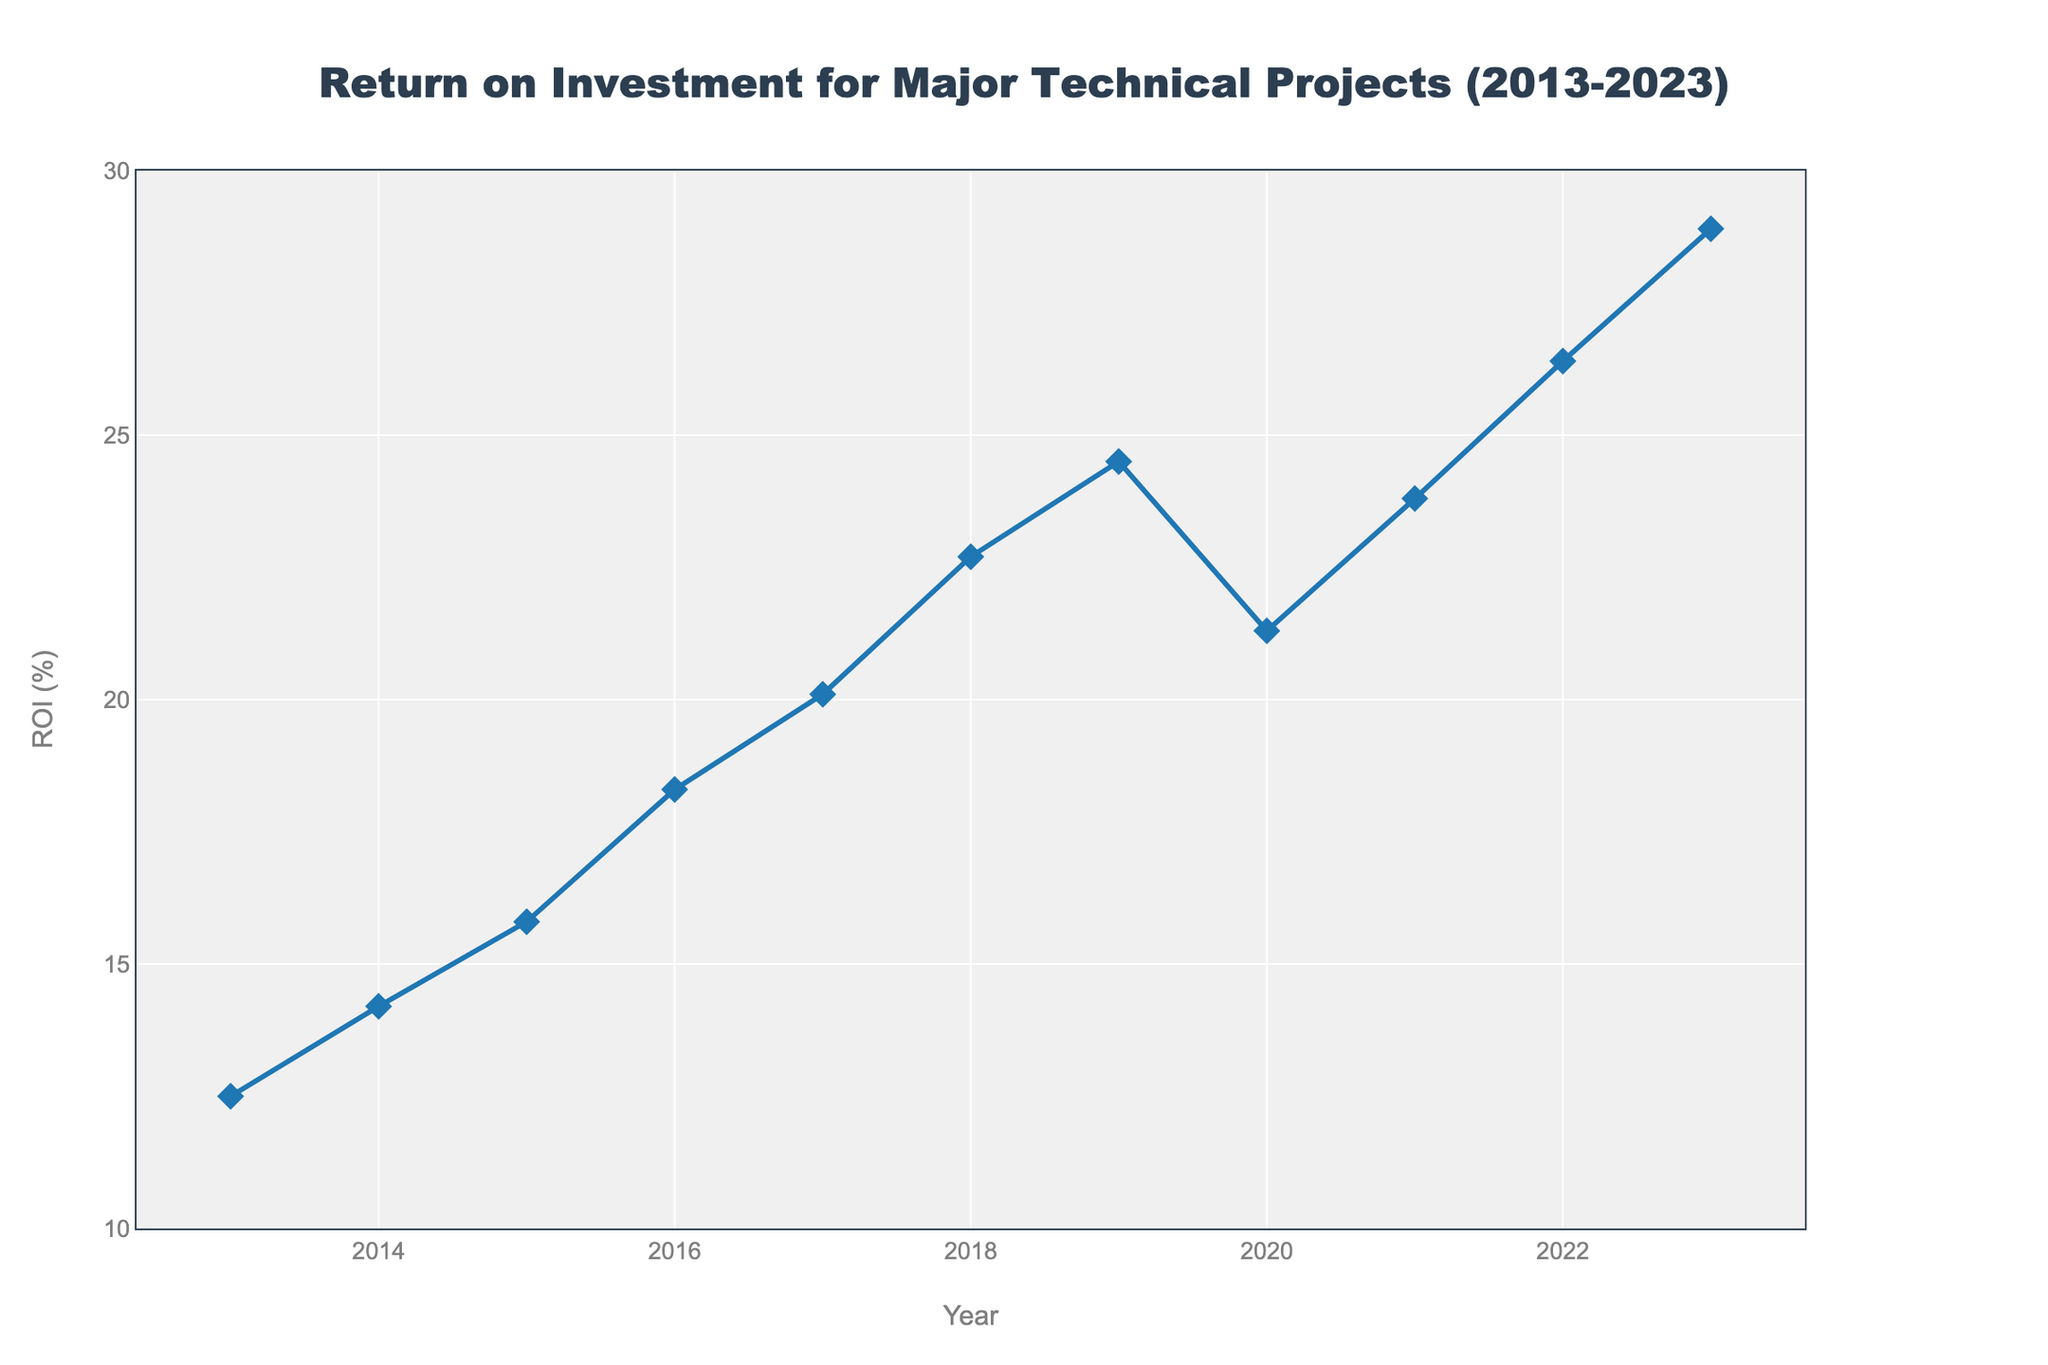What's the highest ROI in the last decade? Look for the peak value on the line chart. The highest ROI is at the year 2023.
Answer: 28.9% What's the lowest ROI in the last decade? Look for the trough in the line chart. The lowest ROI is at the year 2013.
Answer: 12.5% How much did the ROI change from 2019 to 2020? Subtract the ROI of 2019 (24.5%) from the ROI of 2020 (21.3%). The change is a decrease.
Answer: -3.2% Which year saw the largest increase in ROI compared to the previous year? Calculate the year-on-year differences and find the largest one. 2018 -> 2019 saw an increase of 1.8%, 2016 -> 2017 saw an increase of 1.8%, while 2021 -> 2022 saw the largest increase of 2.6%.
Answer: 2021-2022 Which year had an ROI exactly halfway between the lowest and highest values observed? The lowest ROI is 12.5% (2013), and the highest is 28.9% (2023). Halfway is (12.5 + 28.9)/2 = 20.7%. The closest value to 20.7% is in 2017, which is 20.1%.
Answer: 2017 How many years experienced a decline in ROI compared to the previous year? Assess each year and count the instances where the ROI is lower than the previous year. Only 2020 experienced a decline compared to 2019.
Answer: 1 year What's the average ROI over the last decade? Sum all ROI values and divide by the number of years. (12.5 + 14.2 + 15.8 + 18.3 + 20.1 + 22.7 + 24.5 + 21.3 + 23.8 + 26.4 + 28.9)/11 = approx 20.9%.
Answer: 20.9% Compare the ROI of the first and last year in the dataset and state the difference. Subtract the ROI of 2013 (12.5%) from that of 2023 (28.9%).
Answer: 16.4% Identify a year where the ROI remained approximately stable (less than a 1% change) compared to the previous year. Analyze the differences year-by-year. The year 2021 had a difference of 2.5% from 2020, ruling it out. This doesn't occur as there is no year where change is less than 1%.
Answer: None 